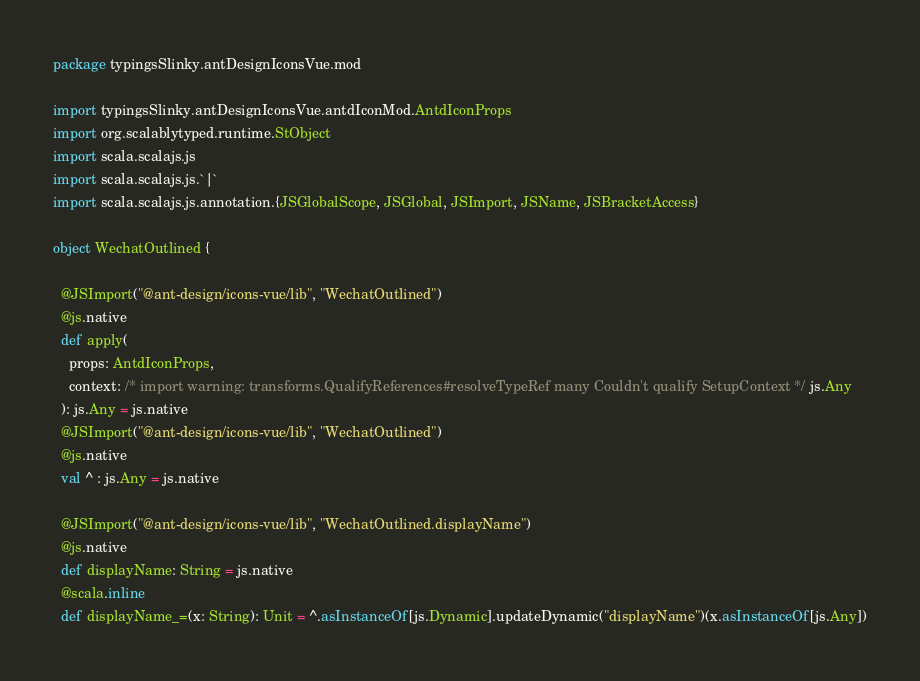Convert code to text. <code><loc_0><loc_0><loc_500><loc_500><_Scala_>package typingsSlinky.antDesignIconsVue.mod

import typingsSlinky.antDesignIconsVue.antdIconMod.AntdIconProps
import org.scalablytyped.runtime.StObject
import scala.scalajs.js
import scala.scalajs.js.`|`
import scala.scalajs.js.annotation.{JSGlobalScope, JSGlobal, JSImport, JSName, JSBracketAccess}

object WechatOutlined {
  
  @JSImport("@ant-design/icons-vue/lib", "WechatOutlined")
  @js.native
  def apply(
    props: AntdIconProps,
    context: /* import warning: transforms.QualifyReferences#resolveTypeRef many Couldn't qualify SetupContext */ js.Any
  ): js.Any = js.native
  @JSImport("@ant-design/icons-vue/lib", "WechatOutlined")
  @js.native
  val ^ : js.Any = js.native
  
  @JSImport("@ant-design/icons-vue/lib", "WechatOutlined.displayName")
  @js.native
  def displayName: String = js.native
  @scala.inline
  def displayName_=(x: String): Unit = ^.asInstanceOf[js.Dynamic].updateDynamic("displayName")(x.asInstanceOf[js.Any])</code> 